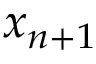<formula> <loc_0><loc_0><loc_500><loc_500>x _ { n + 1 }</formula> 